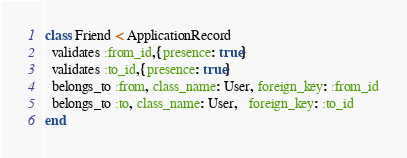Convert code to text. <code><loc_0><loc_0><loc_500><loc_500><_Ruby_>class Friend < ApplicationRecord
  validates :from_id,{presence: true}
  validates :to_id,{presence: true}
  belongs_to :from, class_name: User, foreign_key: :from_id
  belongs_to :to, class_name: User,   foreign_key: :to_id
end
</code> 